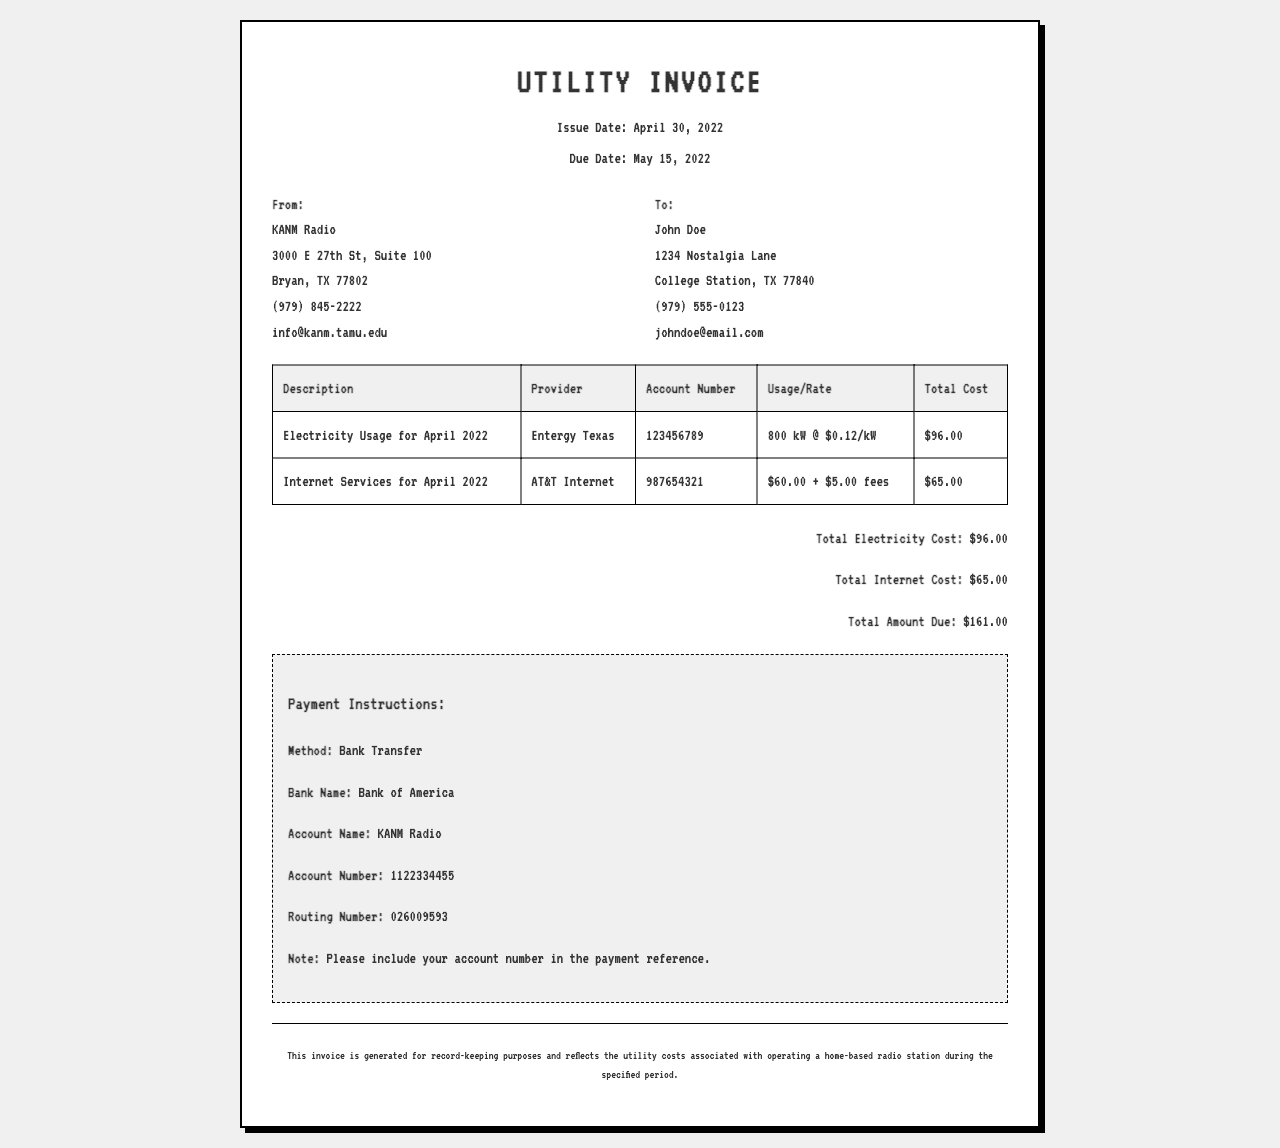what is the issue date of the invoice? The issue date is explicitly stated in the document header as April 30, 2022.
Answer: April 30, 2022 who is the electricity provider? The electricity provider is mentioned in the usage table for electricity.
Answer: Entergy Texas what is the total amount due? The total amount due is calculated and presented in the summary section of the invoice.
Answer: $161.00 what is the account number for internet services? The account number for internet services is provided in the service details for internet.
Answer: 987654321 how much is the electricity usage for April 2022? The document specifies the total cost for electricity usage as indicated in the usage table.
Answer: $96.00 what is the payment method? The payment method is outlined in the payment instructions section.
Answer: Bank Transfer how much are the additional fees for internet services? The additional fees for internet services are broken down in the usage details for internet.
Answer: $5.00 what is the name of the bank for payments? The bank name is clearly mentioned in the payment instructions section of the document.
Answer: Bank of America how many kilowatts were used for electricity? The document specifies the electricity usage in kilowatts in the usage table.
Answer: 800 kW 